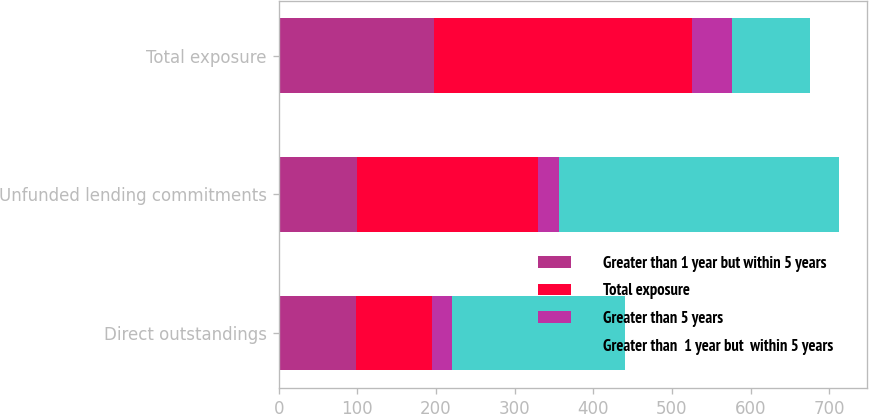<chart> <loc_0><loc_0><loc_500><loc_500><stacked_bar_chart><ecel><fcel>Direct outstandings<fcel>Unfunded lending commitments<fcel>Total exposure<nl><fcel>Greater than 1 year but within 5 years<fcel>98<fcel>99<fcel>197<nl><fcel>Total exposure<fcel>97<fcel>231<fcel>328<nl><fcel>Greater than 5 years<fcel>25<fcel>26<fcel>51<nl><fcel>Greater than  1 year but  within 5 years<fcel>220<fcel>356<fcel>99<nl></chart> 